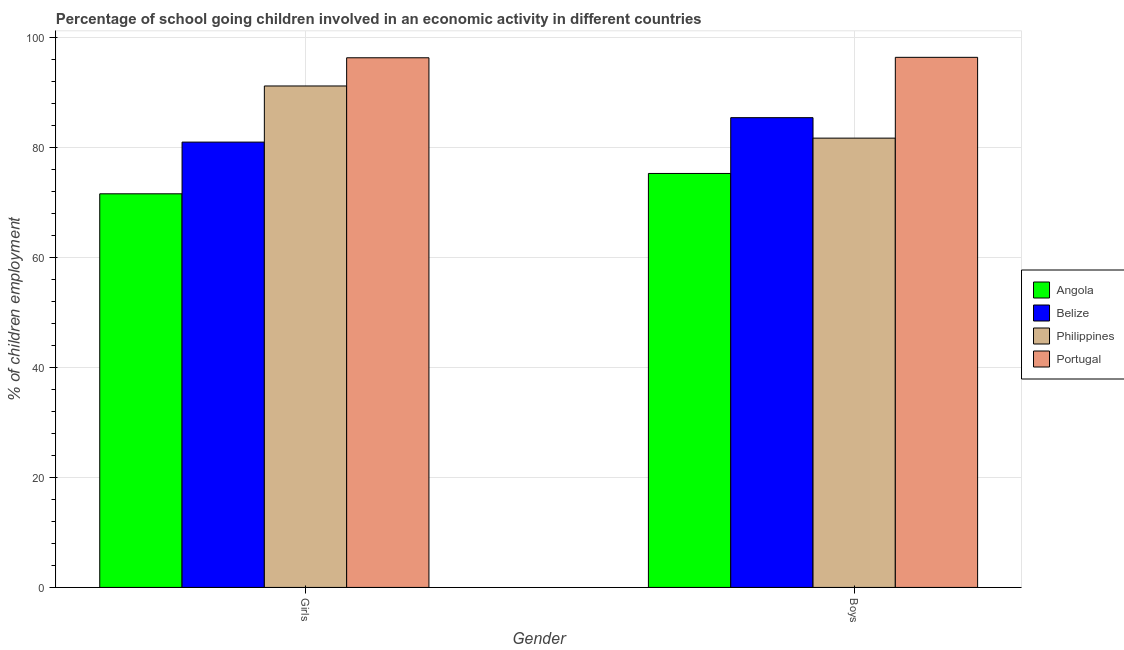How many different coloured bars are there?
Provide a short and direct response. 4. How many groups of bars are there?
Your response must be concise. 2. How many bars are there on the 2nd tick from the left?
Offer a terse response. 4. How many bars are there on the 2nd tick from the right?
Your answer should be very brief. 4. What is the label of the 1st group of bars from the left?
Your response must be concise. Girls. What is the percentage of school going girls in Belize?
Keep it short and to the point. 81. Across all countries, what is the maximum percentage of school going boys?
Provide a succinct answer. 96.42. Across all countries, what is the minimum percentage of school going girls?
Provide a succinct answer. 71.6. In which country was the percentage of school going girls minimum?
Give a very brief answer. Angola. What is the total percentage of school going girls in the graph?
Offer a very short reply. 340.16. What is the difference between the percentage of school going girls in Angola and that in Philippines?
Offer a terse response. -19.61. What is the difference between the percentage of school going boys in Angola and the percentage of school going girls in Portugal?
Ensure brevity in your answer.  -21.04. What is the average percentage of school going girls per country?
Your answer should be compact. 85.04. What is the difference between the percentage of school going girls and percentage of school going boys in Portugal?
Keep it short and to the point. -0.08. What is the ratio of the percentage of school going boys in Belize to that in Angola?
Ensure brevity in your answer.  1.13. Is the percentage of school going boys in Angola less than that in Portugal?
Your answer should be compact. Yes. In how many countries, is the percentage of school going boys greater than the average percentage of school going boys taken over all countries?
Ensure brevity in your answer.  2. What does the 4th bar from the left in Boys represents?
Your answer should be very brief. Portugal. What does the 4th bar from the right in Boys represents?
Make the answer very short. Angola. Are all the bars in the graph horizontal?
Offer a terse response. No. How many countries are there in the graph?
Give a very brief answer. 4. Does the graph contain any zero values?
Offer a very short reply. No. Does the graph contain grids?
Give a very brief answer. Yes. How many legend labels are there?
Offer a terse response. 4. How are the legend labels stacked?
Keep it short and to the point. Vertical. What is the title of the graph?
Provide a short and direct response. Percentage of school going children involved in an economic activity in different countries. Does "Australia" appear as one of the legend labels in the graph?
Your response must be concise. No. What is the label or title of the X-axis?
Offer a very short reply. Gender. What is the label or title of the Y-axis?
Keep it short and to the point. % of children employment. What is the % of children employment in Angola in Girls?
Your answer should be compact. 71.6. What is the % of children employment in Belize in Girls?
Your answer should be very brief. 81. What is the % of children employment in Philippines in Girls?
Your response must be concise. 91.21. What is the % of children employment of Portugal in Girls?
Offer a terse response. 96.34. What is the % of children employment of Angola in Boys?
Keep it short and to the point. 75.3. What is the % of children employment of Belize in Boys?
Provide a succinct answer. 85.45. What is the % of children employment in Philippines in Boys?
Ensure brevity in your answer.  81.73. What is the % of children employment in Portugal in Boys?
Make the answer very short. 96.42. Across all Gender, what is the maximum % of children employment of Angola?
Your answer should be compact. 75.3. Across all Gender, what is the maximum % of children employment in Belize?
Offer a terse response. 85.45. Across all Gender, what is the maximum % of children employment in Philippines?
Provide a short and direct response. 91.21. Across all Gender, what is the maximum % of children employment in Portugal?
Provide a short and direct response. 96.42. Across all Gender, what is the minimum % of children employment in Angola?
Provide a short and direct response. 71.6. Across all Gender, what is the minimum % of children employment of Belize?
Provide a short and direct response. 81. Across all Gender, what is the minimum % of children employment of Philippines?
Offer a very short reply. 81.73. Across all Gender, what is the minimum % of children employment of Portugal?
Ensure brevity in your answer.  96.34. What is the total % of children employment in Angola in the graph?
Offer a terse response. 146.9. What is the total % of children employment in Belize in the graph?
Offer a terse response. 166.45. What is the total % of children employment in Philippines in the graph?
Provide a succinct answer. 172.94. What is the total % of children employment in Portugal in the graph?
Ensure brevity in your answer.  192.77. What is the difference between the % of children employment in Angola in Girls and that in Boys?
Offer a terse response. -3.7. What is the difference between the % of children employment in Belize in Girls and that in Boys?
Keep it short and to the point. -4.45. What is the difference between the % of children employment of Philippines in Girls and that in Boys?
Keep it short and to the point. 9.49. What is the difference between the % of children employment in Portugal in Girls and that in Boys?
Your answer should be very brief. -0.08. What is the difference between the % of children employment in Angola in Girls and the % of children employment in Belize in Boys?
Give a very brief answer. -13.85. What is the difference between the % of children employment of Angola in Girls and the % of children employment of Philippines in Boys?
Offer a very short reply. -10.13. What is the difference between the % of children employment of Angola in Girls and the % of children employment of Portugal in Boys?
Provide a short and direct response. -24.82. What is the difference between the % of children employment in Belize in Girls and the % of children employment in Philippines in Boys?
Your answer should be very brief. -0.72. What is the difference between the % of children employment of Belize in Girls and the % of children employment of Portugal in Boys?
Your answer should be compact. -15.42. What is the difference between the % of children employment of Philippines in Girls and the % of children employment of Portugal in Boys?
Your answer should be compact. -5.21. What is the average % of children employment of Angola per Gender?
Keep it short and to the point. 73.45. What is the average % of children employment in Belize per Gender?
Offer a terse response. 83.23. What is the average % of children employment in Philippines per Gender?
Keep it short and to the point. 86.47. What is the average % of children employment in Portugal per Gender?
Your response must be concise. 96.38. What is the difference between the % of children employment in Angola and % of children employment in Belize in Girls?
Offer a terse response. -9.4. What is the difference between the % of children employment of Angola and % of children employment of Philippines in Girls?
Make the answer very short. -19.61. What is the difference between the % of children employment of Angola and % of children employment of Portugal in Girls?
Keep it short and to the point. -24.74. What is the difference between the % of children employment of Belize and % of children employment of Philippines in Girls?
Your response must be concise. -10.21. What is the difference between the % of children employment in Belize and % of children employment in Portugal in Girls?
Provide a succinct answer. -15.34. What is the difference between the % of children employment of Philippines and % of children employment of Portugal in Girls?
Keep it short and to the point. -5.13. What is the difference between the % of children employment in Angola and % of children employment in Belize in Boys?
Provide a succinct answer. -10.15. What is the difference between the % of children employment in Angola and % of children employment in Philippines in Boys?
Ensure brevity in your answer.  -6.43. What is the difference between the % of children employment in Angola and % of children employment in Portugal in Boys?
Make the answer very short. -21.12. What is the difference between the % of children employment in Belize and % of children employment in Philippines in Boys?
Offer a very short reply. 3.72. What is the difference between the % of children employment in Belize and % of children employment in Portugal in Boys?
Your answer should be compact. -10.97. What is the difference between the % of children employment of Philippines and % of children employment of Portugal in Boys?
Your response must be concise. -14.7. What is the ratio of the % of children employment in Angola in Girls to that in Boys?
Your answer should be compact. 0.95. What is the ratio of the % of children employment of Belize in Girls to that in Boys?
Ensure brevity in your answer.  0.95. What is the ratio of the % of children employment of Philippines in Girls to that in Boys?
Provide a succinct answer. 1.12. What is the ratio of the % of children employment in Portugal in Girls to that in Boys?
Your response must be concise. 1. What is the difference between the highest and the second highest % of children employment in Belize?
Give a very brief answer. 4.45. What is the difference between the highest and the second highest % of children employment in Philippines?
Provide a short and direct response. 9.49. What is the difference between the highest and the second highest % of children employment of Portugal?
Keep it short and to the point. 0.08. What is the difference between the highest and the lowest % of children employment of Belize?
Provide a succinct answer. 4.45. What is the difference between the highest and the lowest % of children employment in Philippines?
Make the answer very short. 9.49. What is the difference between the highest and the lowest % of children employment of Portugal?
Offer a terse response. 0.08. 